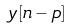Convert formula to latex. <formula><loc_0><loc_0><loc_500><loc_500>y [ n - p ]</formula> 